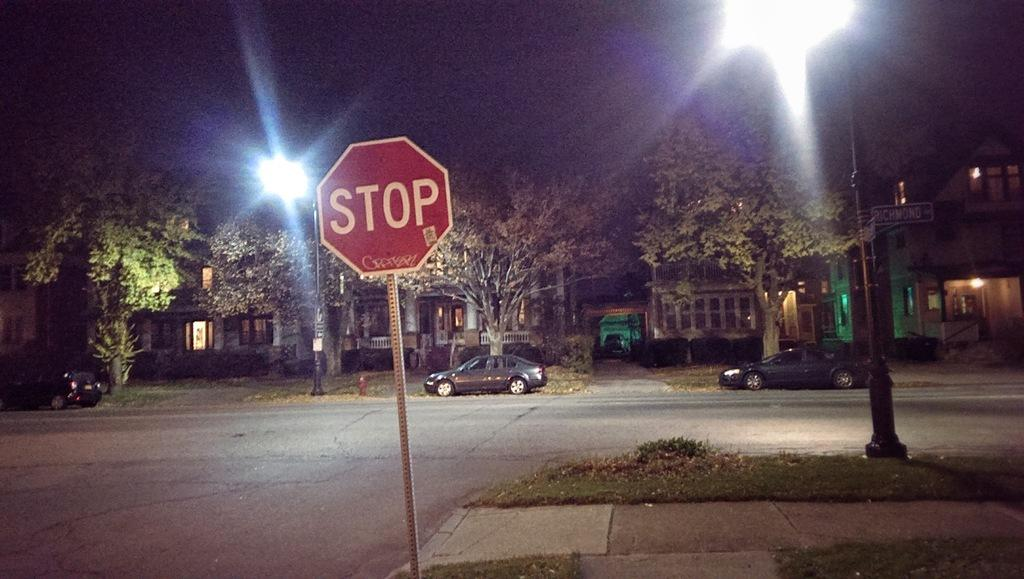<image>
Give a short and clear explanation of the subsequent image. A stop sign stands on the edge of the road near the sidewalk. 